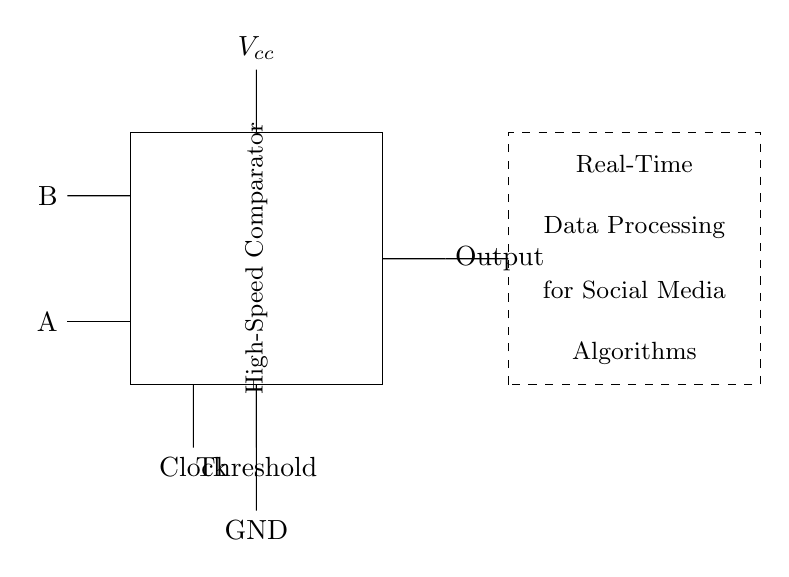What are the two input signals? The input signals are labeled as A and B in the circuit, indicating the two digital inputs for the comparator.
Answer: A, B What type of component is shown in the middle of the diagram? The component in the middle is a high-speed comparator, which is a crucial part of this circuit for comparing the input signals.
Answer: High-Speed Comparator What is the purpose of the threshold connection? The threshold connection is used to set the reference voltage at which the comparator will decide the output, affecting its operation.
Answer: Reference voltage What are the two outputs of the circuit? The circuit has a single output labeled as "Output," which is the result produced by the comparator based on the inputs A and B.
Answer: Output How is the power supplied to the circuit? The power is supplied through a voltage source connected at the point labeled Vcc, which indicates the positive supply voltage for the circuit operation.
Answer: Voltage source Which component defines the speed of data processing in the circuit? The high-speed comparator component is responsible for the speed of data processing as noted in the diagram's description.
Answer: High-Speed Comparator What type of algorithm is mentioned for data processing? The circuit is designed for real-time data processing for social media algorithms, indicating its application in that field.
Answer: Social media algorithms 